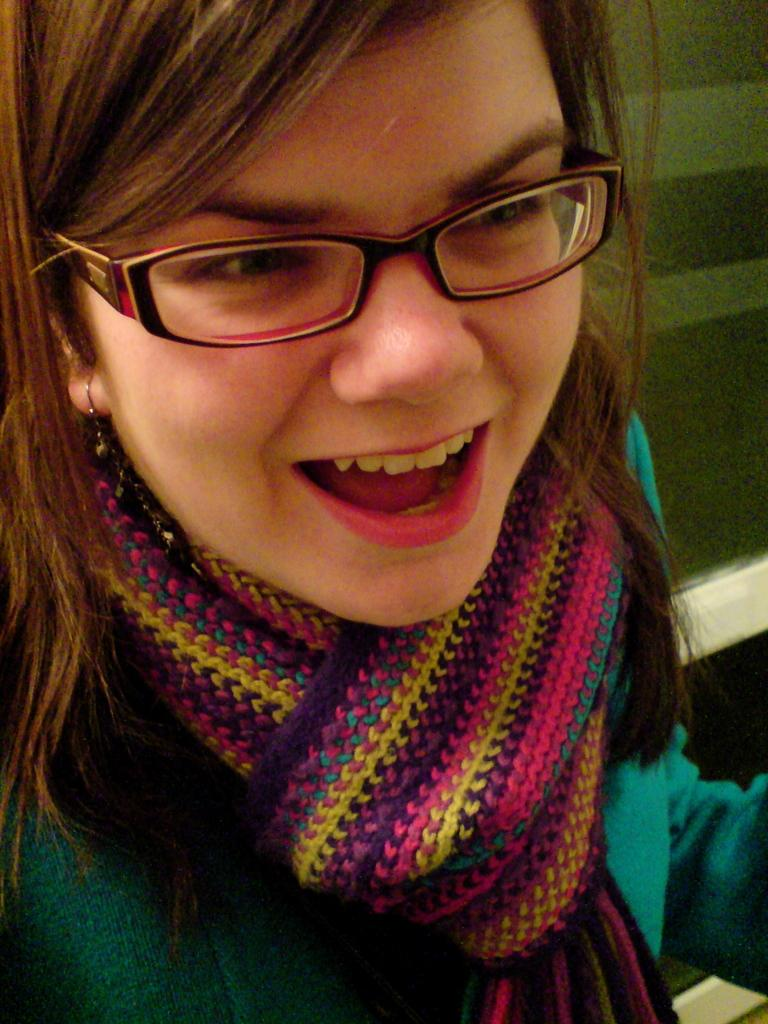Who is the main subject in the image? There is a girl in the image. What is the girl wearing on her face? The girl is wearing specs. What accessory is the girl wearing around her neck? The girl is wearing a scarf on her neck. What can be seen in the background of the image? There is a wall in the background of the image. What type of knife is the girl using to paint the wall in the image? There is no knife or painting activity present in the image. 